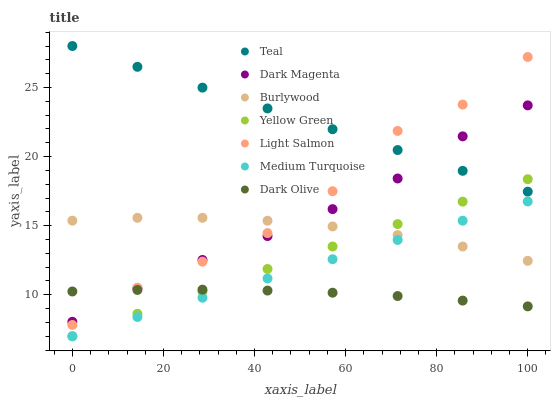Does Dark Olive have the minimum area under the curve?
Answer yes or no. Yes. Does Teal have the maximum area under the curve?
Answer yes or no. Yes. Does Light Salmon have the minimum area under the curve?
Answer yes or no. No. Does Light Salmon have the maximum area under the curve?
Answer yes or no. No. Is Yellow Green the smoothest?
Answer yes or no. Yes. Is Light Salmon the roughest?
Answer yes or no. Yes. Is Dark Magenta the smoothest?
Answer yes or no. No. Is Dark Magenta the roughest?
Answer yes or no. No. Does Medium Turquoise have the lowest value?
Answer yes or no. Yes. Does Light Salmon have the lowest value?
Answer yes or no. No. Does Teal have the highest value?
Answer yes or no. Yes. Does Light Salmon have the highest value?
Answer yes or no. No. Is Medium Turquoise less than Dark Magenta?
Answer yes or no. Yes. Is Teal greater than Medium Turquoise?
Answer yes or no. Yes. Does Yellow Green intersect Medium Turquoise?
Answer yes or no. Yes. Is Yellow Green less than Medium Turquoise?
Answer yes or no. No. Is Yellow Green greater than Medium Turquoise?
Answer yes or no. No. Does Medium Turquoise intersect Dark Magenta?
Answer yes or no. No. 